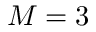<formula> <loc_0><loc_0><loc_500><loc_500>M = 3</formula> 